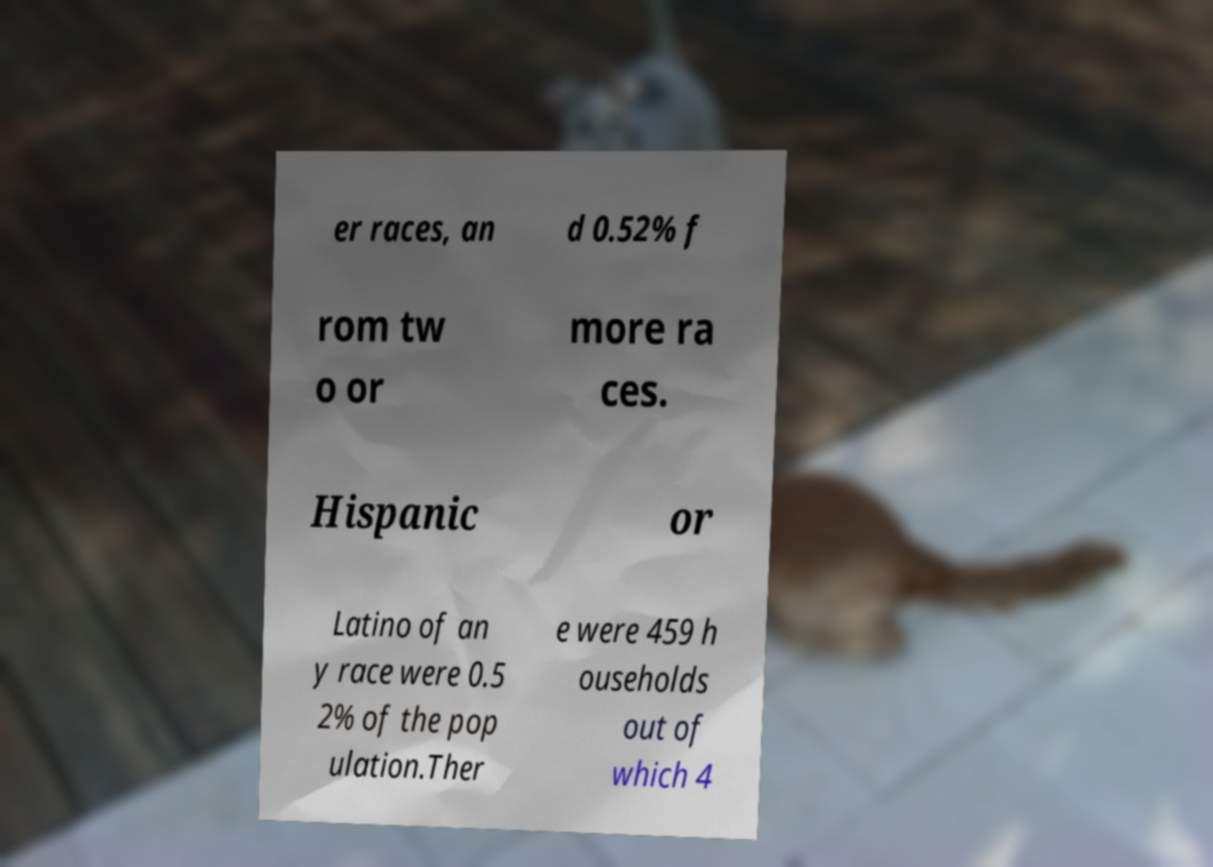Could you extract and type out the text from this image? er races, an d 0.52% f rom tw o or more ra ces. Hispanic or Latino of an y race were 0.5 2% of the pop ulation.Ther e were 459 h ouseholds out of which 4 